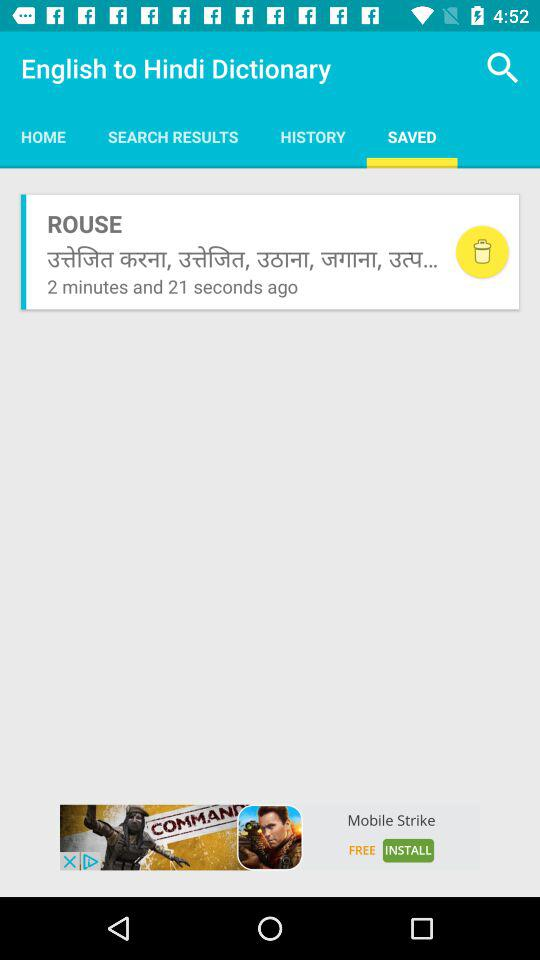What is the application name? The application name is "English to Hindi Dictionary". 